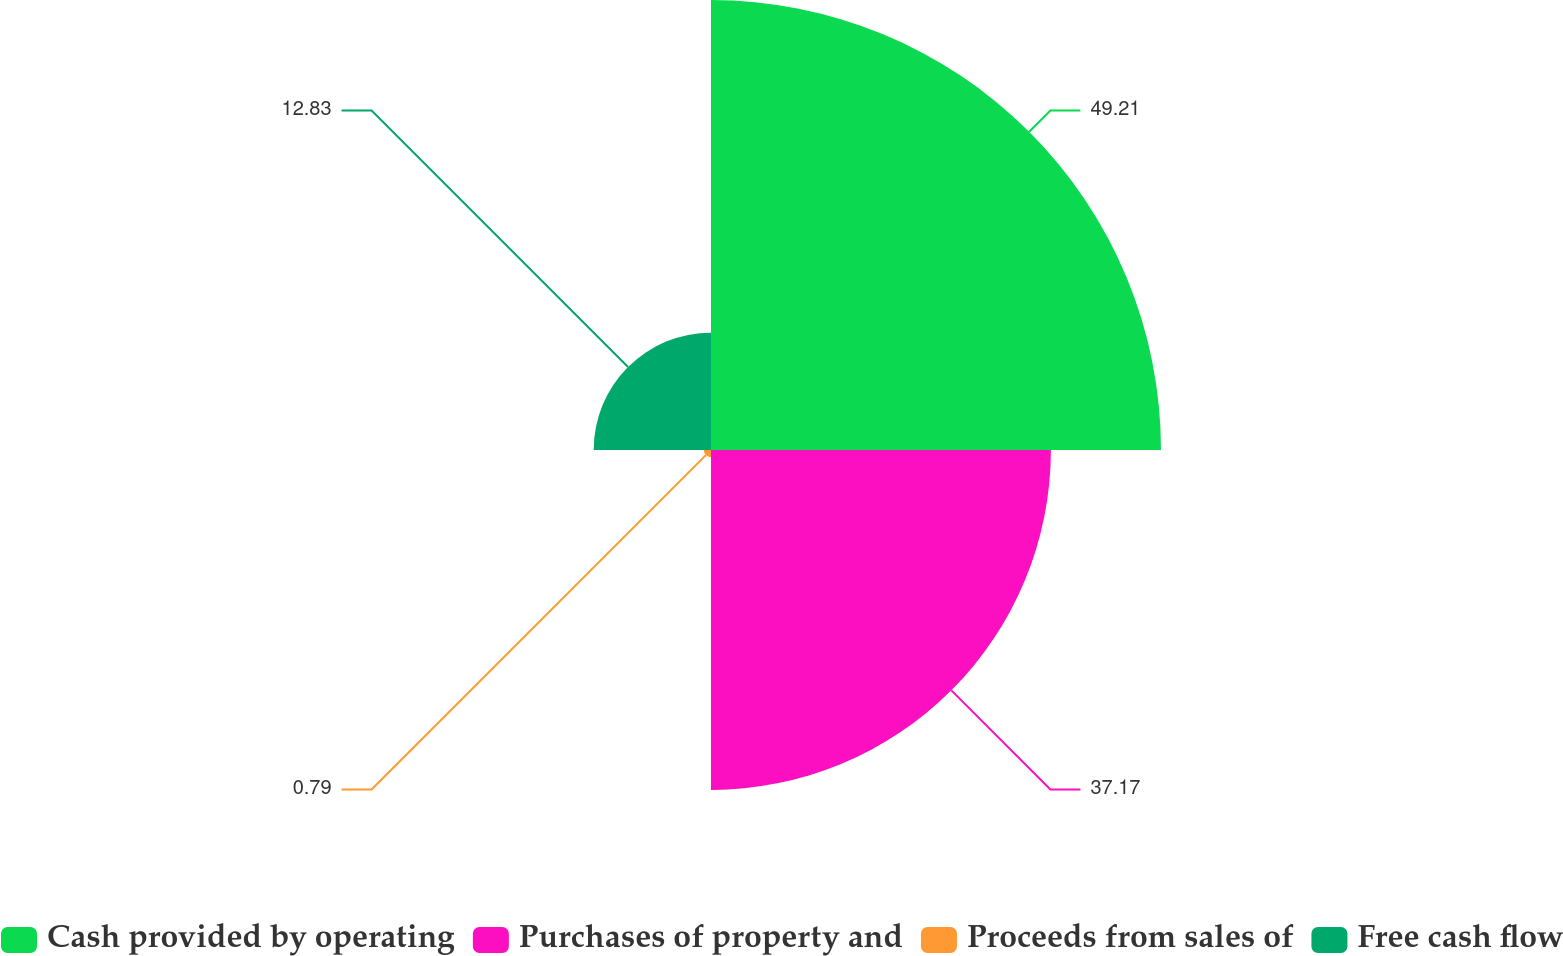Convert chart to OTSL. <chart><loc_0><loc_0><loc_500><loc_500><pie_chart><fcel>Cash provided by operating<fcel>Purchases of property and<fcel>Proceeds from sales of<fcel>Free cash flow<nl><fcel>49.21%<fcel>37.17%<fcel>0.79%<fcel>12.83%<nl></chart> 